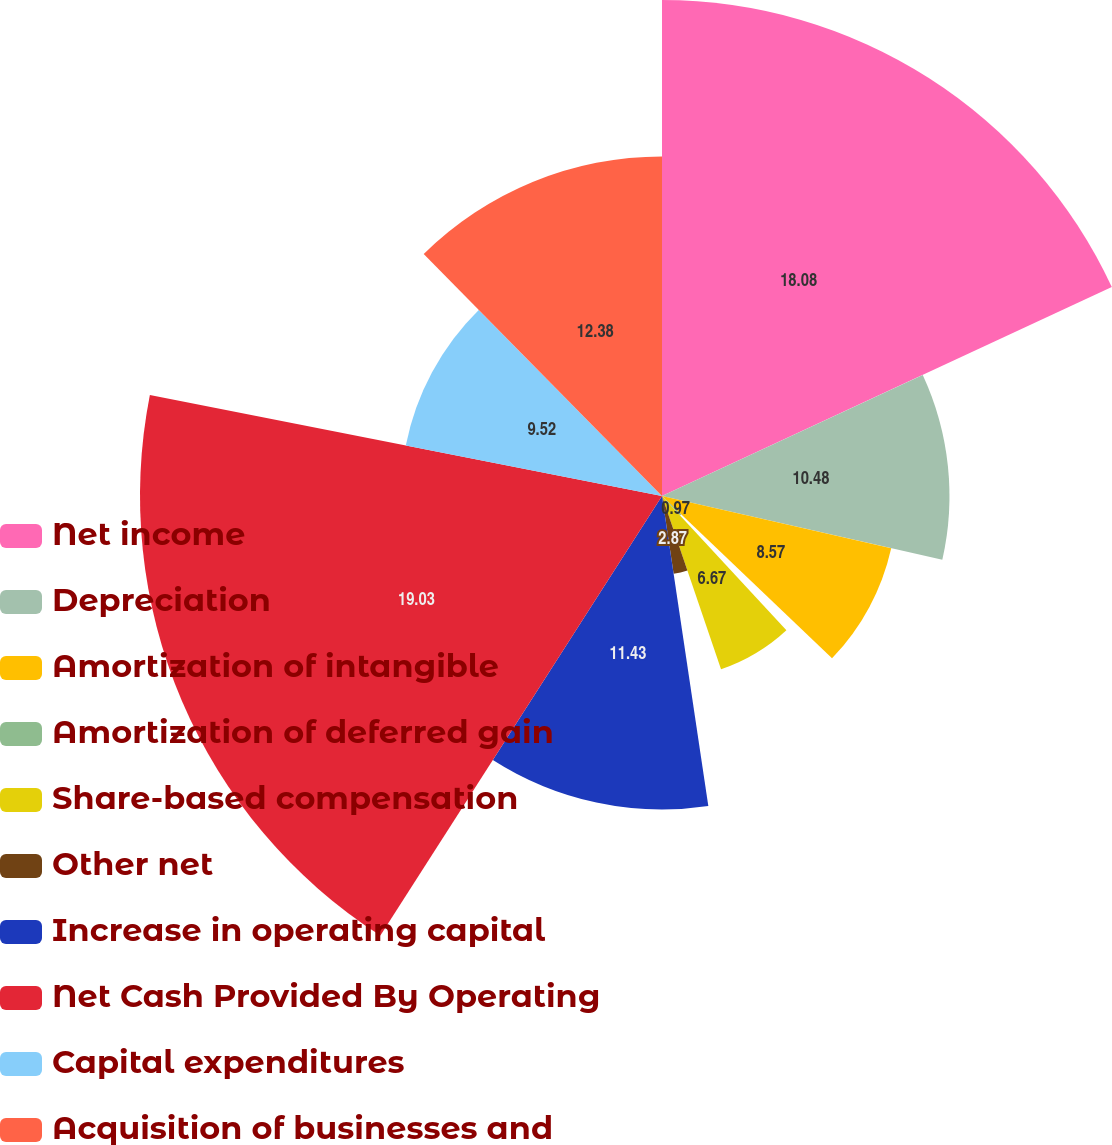<chart> <loc_0><loc_0><loc_500><loc_500><pie_chart><fcel>Net income<fcel>Depreciation<fcel>Amortization of intangible<fcel>Amortization of deferred gain<fcel>Share-based compensation<fcel>Other net<fcel>Increase in operating capital<fcel>Net Cash Provided By Operating<fcel>Capital expenditures<fcel>Acquisition of businesses and<nl><fcel>18.08%<fcel>10.48%<fcel>8.57%<fcel>0.97%<fcel>6.67%<fcel>2.87%<fcel>11.43%<fcel>19.03%<fcel>9.52%<fcel>12.38%<nl></chart> 